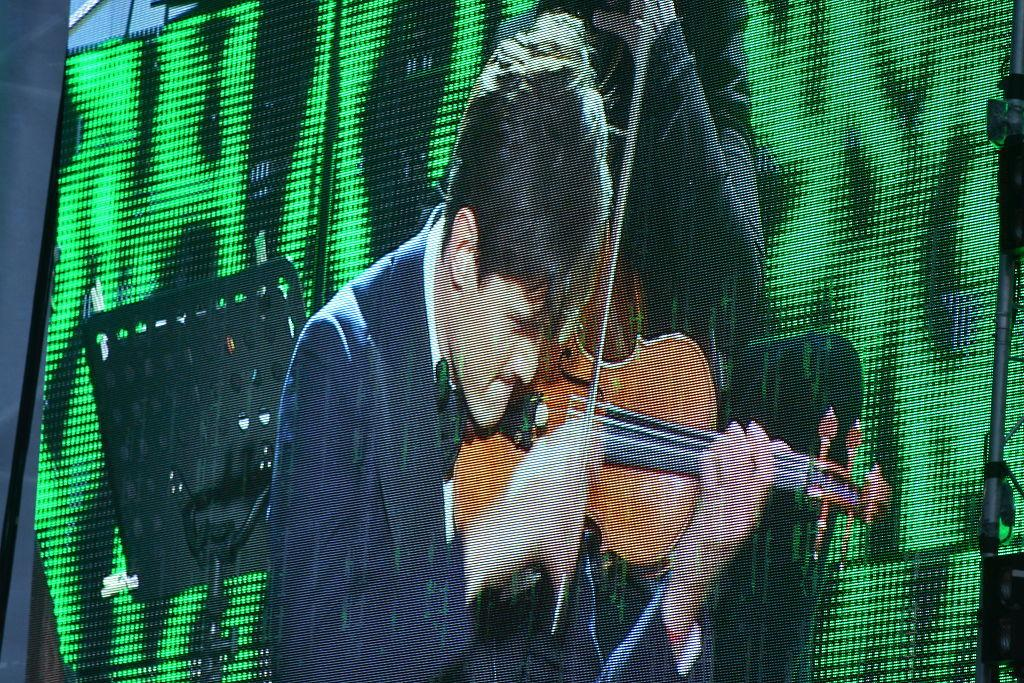What is the main activity being performed in the image? There is a person playing a violin in the image. What object is present to hold sheet music for the violinist? There is a music stand in the image. Can you describe the other person in the image? There is another person standing in the image. What type of desk can be seen in the aftermath of the performance in the image? There is no desk present in the image, nor is there any indication of an aftermath of a performance. 